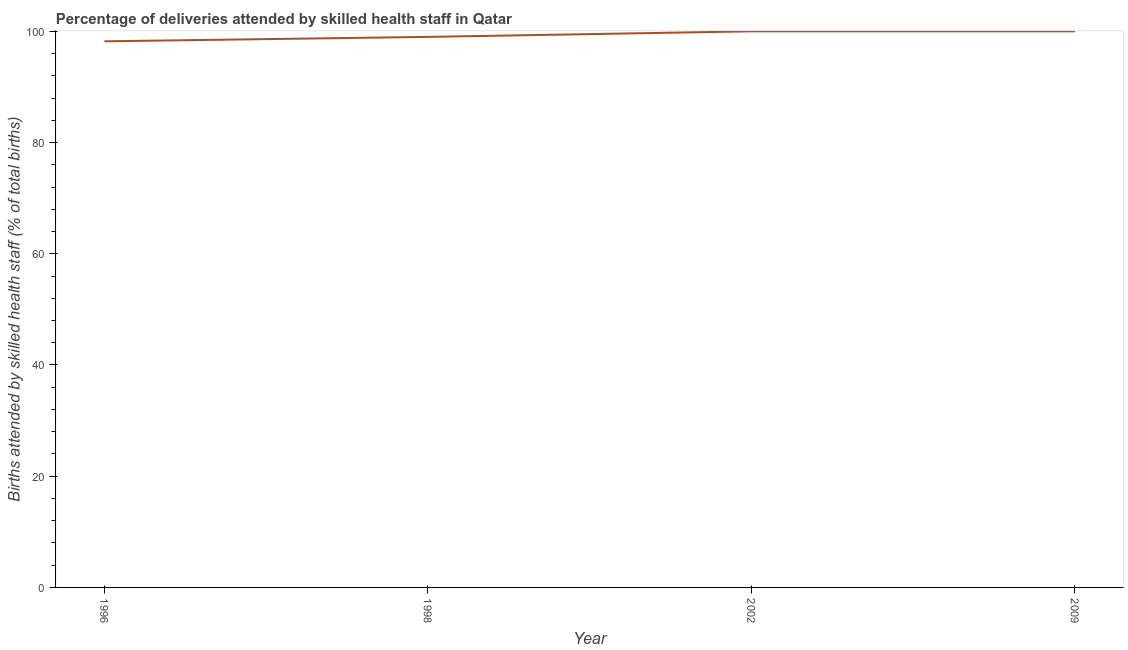Across all years, what is the maximum number of births attended by skilled health staff?
Offer a very short reply. 100. Across all years, what is the minimum number of births attended by skilled health staff?
Ensure brevity in your answer.  98.2. In which year was the number of births attended by skilled health staff maximum?
Provide a short and direct response. 2002. In which year was the number of births attended by skilled health staff minimum?
Provide a short and direct response. 1996. What is the sum of the number of births attended by skilled health staff?
Ensure brevity in your answer.  397.2. What is the difference between the number of births attended by skilled health staff in 1998 and 2002?
Offer a terse response. -1. What is the average number of births attended by skilled health staff per year?
Offer a terse response. 99.3. What is the median number of births attended by skilled health staff?
Your response must be concise. 99.5. Do a majority of the years between 1998 and 2009 (inclusive) have number of births attended by skilled health staff greater than 44 %?
Your answer should be compact. Yes. What is the ratio of the number of births attended by skilled health staff in 1998 to that in 2002?
Offer a terse response. 0.99. What is the difference between the highest and the second highest number of births attended by skilled health staff?
Ensure brevity in your answer.  0. Is the sum of the number of births attended by skilled health staff in 1996 and 1998 greater than the maximum number of births attended by skilled health staff across all years?
Provide a succinct answer. Yes. What is the difference between the highest and the lowest number of births attended by skilled health staff?
Provide a short and direct response. 1.8. How many years are there in the graph?
Ensure brevity in your answer.  4. Does the graph contain any zero values?
Ensure brevity in your answer.  No. What is the title of the graph?
Offer a terse response. Percentage of deliveries attended by skilled health staff in Qatar. What is the label or title of the Y-axis?
Ensure brevity in your answer.  Births attended by skilled health staff (% of total births). What is the Births attended by skilled health staff (% of total births) of 1996?
Make the answer very short. 98.2. What is the difference between the Births attended by skilled health staff (% of total births) in 1996 and 1998?
Your answer should be very brief. -0.8. What is the difference between the Births attended by skilled health staff (% of total births) in 1998 and 2002?
Give a very brief answer. -1. What is the difference between the Births attended by skilled health staff (% of total births) in 1998 and 2009?
Your answer should be compact. -1. What is the ratio of the Births attended by skilled health staff (% of total births) in 1996 to that in 2009?
Provide a succinct answer. 0.98. What is the ratio of the Births attended by skilled health staff (% of total births) in 2002 to that in 2009?
Give a very brief answer. 1. 